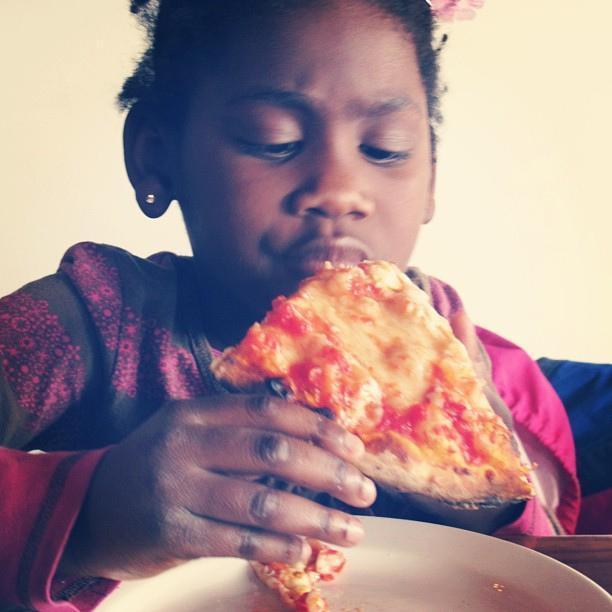Is the given caption "The pizza is touching the person." fitting for the image?
Answer yes or no. Yes. 